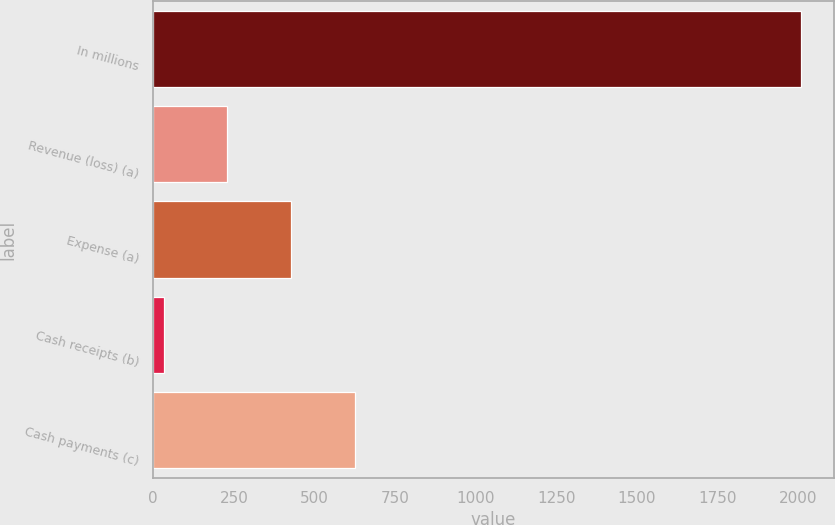Convert chart. <chart><loc_0><loc_0><loc_500><loc_500><bar_chart><fcel>In millions<fcel>Revenue (loss) (a)<fcel>Expense (a)<fcel>Cash receipts (b)<fcel>Cash payments (c)<nl><fcel>2010<fcel>229.8<fcel>427.6<fcel>32<fcel>625.4<nl></chart> 